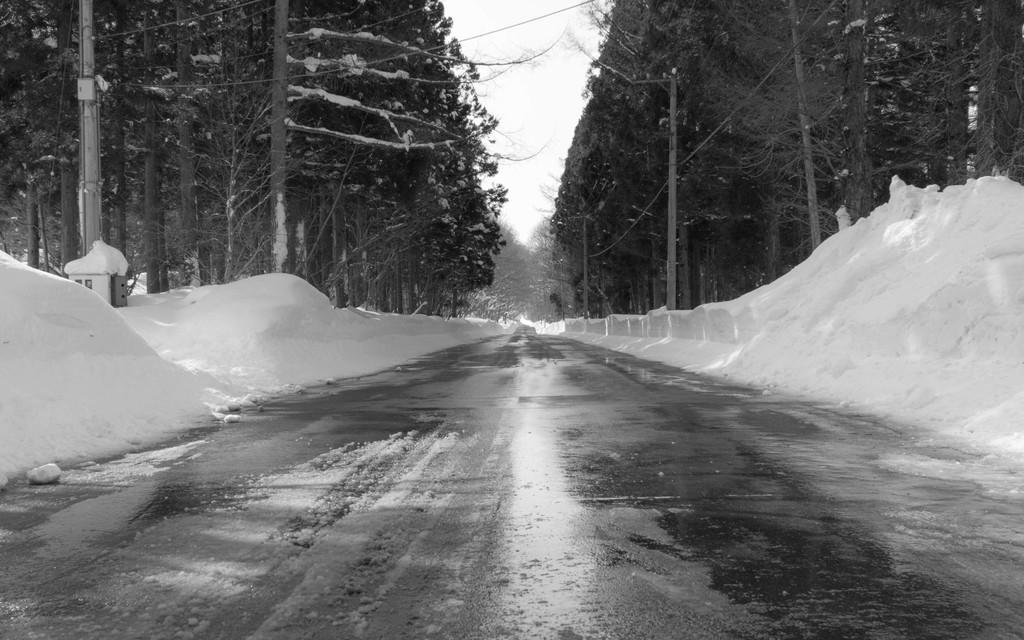What type of picture is in the image? The image contains a black and white picture. What natural elements are present in the picture? There is a group of trees in the picture. What man-made structures can be seen in the picture? There are poles in the picture. What is the pathway used for in the picture? The pathway is likely used for walking or traveling through the area. What can be seen in the background of the picture? The sky is visible in the background of the picture. What arithmetic problem is being solved by the trees in the picture? There is no arithmetic problem being solved by the trees in the picture; they are simply a natural element in the scene. 